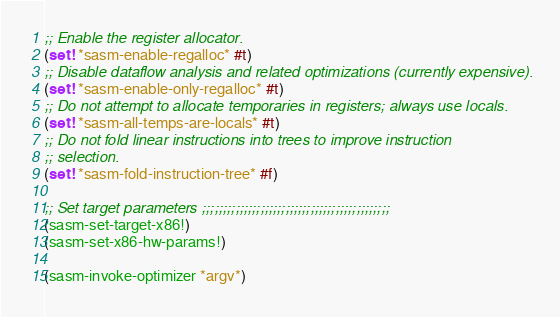<code> <loc_0><loc_0><loc_500><loc_500><_Scheme_>;; Enable the register allocator.
(set! *sasm-enable-regalloc* #t)
;; Disable dataflow analysis and related optimizations (currently expensive).
(set! *sasm-enable-only-regalloc* #t)
;; Do not attempt to allocate temporaries in registers; always use locals.
(set! *sasm-all-temps-are-locals* #t)
;; Do not fold linear instructions into trees to improve instruction
;; selection.
(set! *sasm-fold-instruction-tree* #f)

;; Set target parameters ;;;;;;;;;;;;;;;;;;;;;;;;;;;;;;;;;;;;;;;;;;;;;
(sasm-set-target-x86!)
(sasm-set-x86-hw-params!)

(sasm-invoke-optimizer *argv*)
</code> 